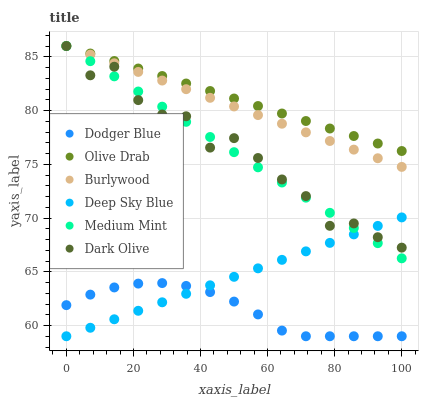Does Dodger Blue have the minimum area under the curve?
Answer yes or no. Yes. Does Olive Drab have the maximum area under the curve?
Answer yes or no. Yes. Does Burlywood have the minimum area under the curve?
Answer yes or no. No. Does Burlywood have the maximum area under the curve?
Answer yes or no. No. Is Medium Mint the smoothest?
Answer yes or no. Yes. Is Dark Olive the roughest?
Answer yes or no. Yes. Is Burlywood the smoothest?
Answer yes or no. No. Is Burlywood the roughest?
Answer yes or no. No. Does Dodger Blue have the lowest value?
Answer yes or no. Yes. Does Burlywood have the lowest value?
Answer yes or no. No. Does Olive Drab have the highest value?
Answer yes or no. Yes. Does Dodger Blue have the highest value?
Answer yes or no. No. Is Dodger Blue less than Dark Olive?
Answer yes or no. Yes. Is Olive Drab greater than Deep Sky Blue?
Answer yes or no. Yes. Does Deep Sky Blue intersect Dark Olive?
Answer yes or no. Yes. Is Deep Sky Blue less than Dark Olive?
Answer yes or no. No. Is Deep Sky Blue greater than Dark Olive?
Answer yes or no. No. Does Dodger Blue intersect Dark Olive?
Answer yes or no. No. 